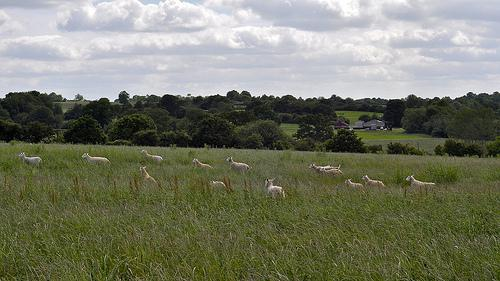Question: what is in the field?
Choices:
A. Cattle.
B. Chickens.
C. Goats.
D. Sheep.
Answer with the letter. Answer: D Question: where are they?
Choices:
A. In a pasture.
B. In the ZOO.
C. In the forest.
D. At the lakeshore.
Answer with the letter. Answer: A Question: what else do sheep produce?
Choices:
A. Cheese.
B. Lambs and mutton.
C. Milk.
D. Wool.
Answer with the letter. Answer: B Question: how many sheep are there?
Choices:
A. At least 13.
B. 12.
C. 11.
D. 9.
Answer with the letter. Answer: A Question: what do they eat?
Choices:
A. Grasses.
B. Leaves.
C. Insects.
D. Fruits and vegetables.
Answer with the letter. Answer: A 